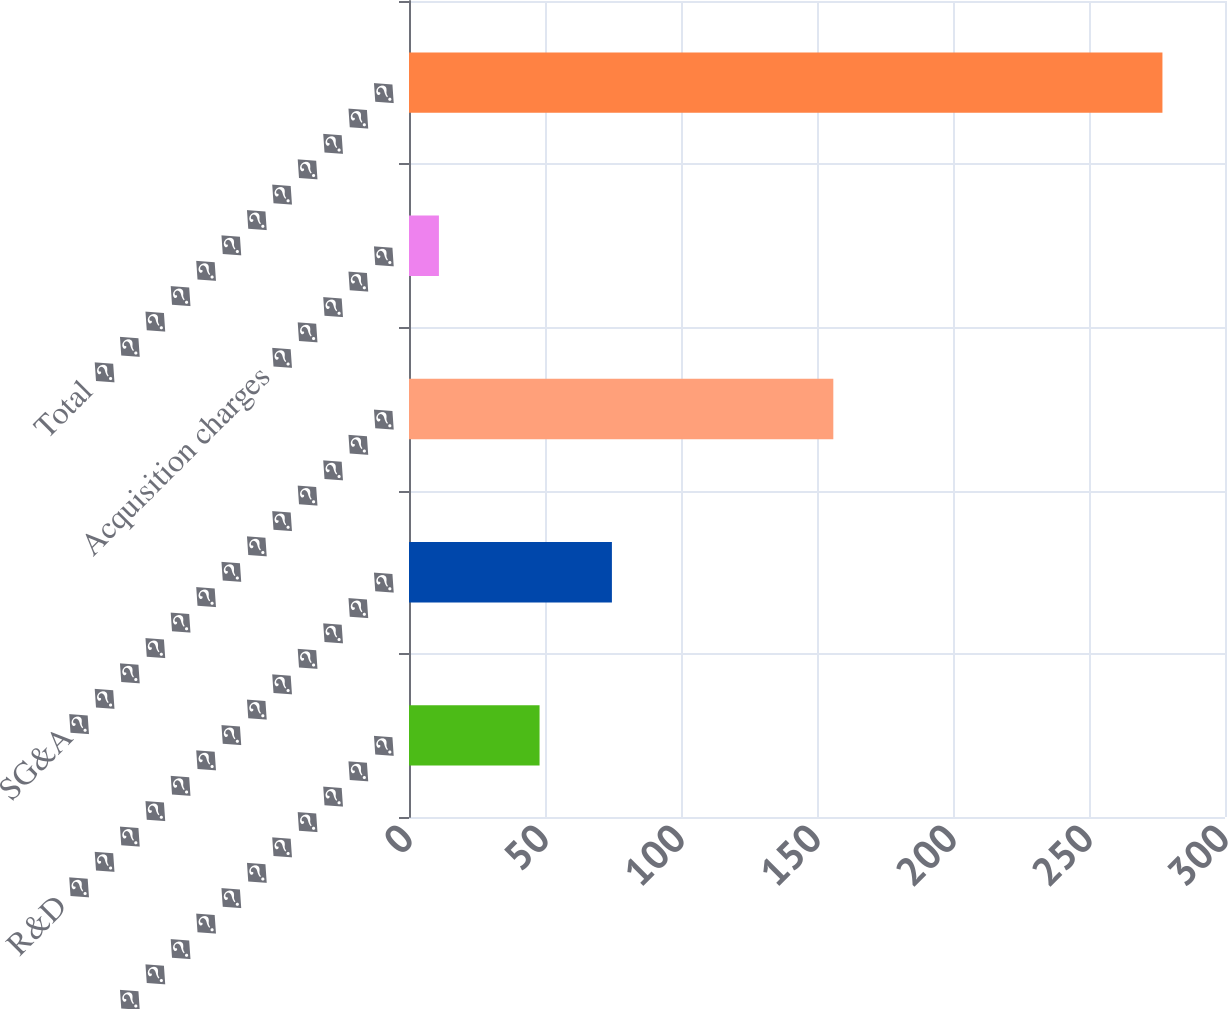<chart> <loc_0><loc_0><loc_500><loc_500><bar_chart><fcel>COR � � � � � � � � � � � � �<fcel>R&D � � � � � � � � � � � � �<fcel>SG&A� � � � � � � � � � � � �<fcel>Acquisition charges � � � � �<fcel>Total � � � � � � � � � � � �<nl><fcel>48<fcel>74.6<fcel>156<fcel>11<fcel>277<nl></chart> 